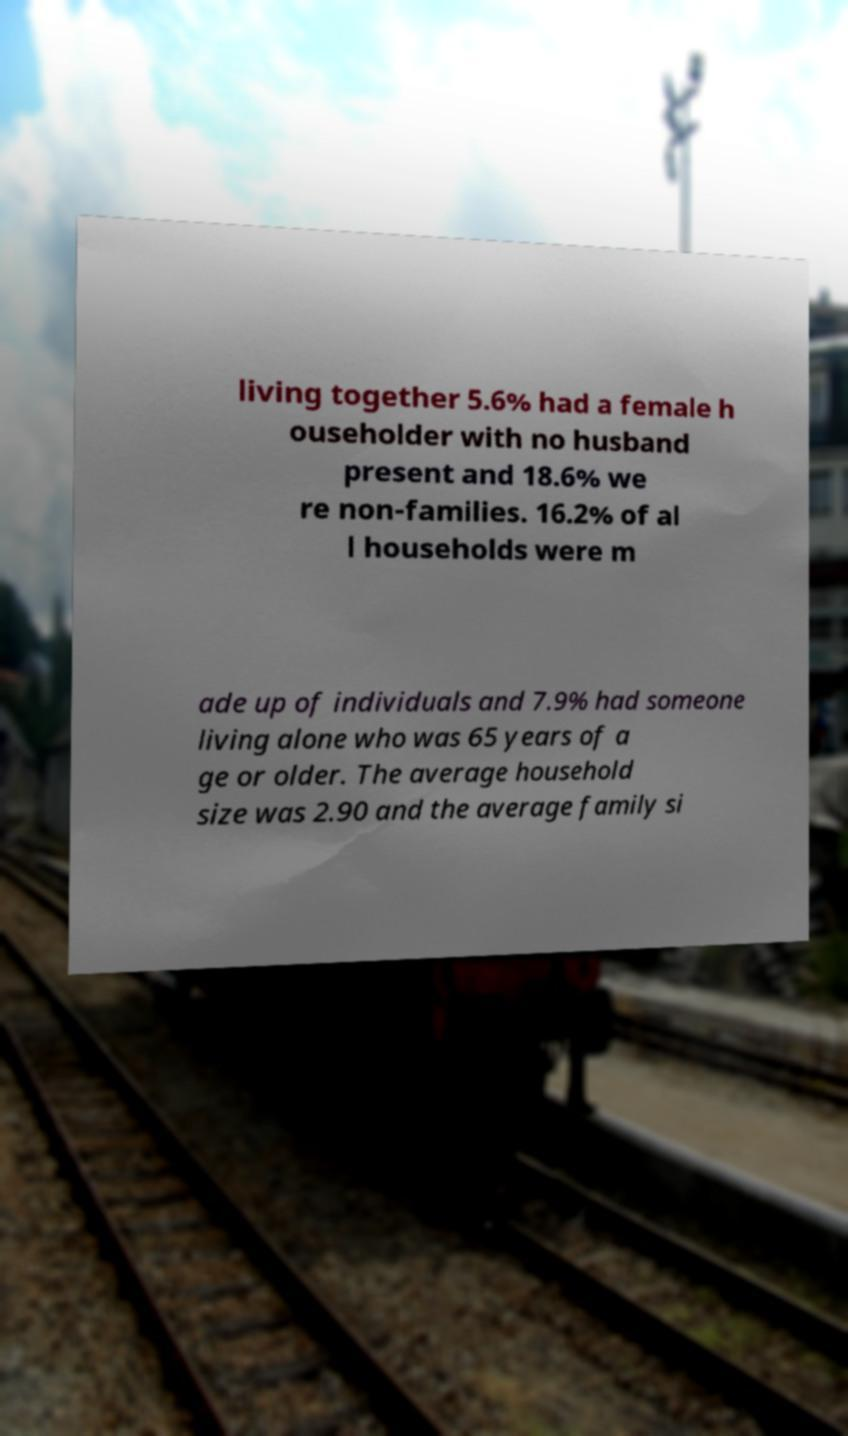There's text embedded in this image that I need extracted. Can you transcribe it verbatim? living together 5.6% had a female h ouseholder with no husband present and 18.6% we re non-families. 16.2% of al l households were m ade up of individuals and 7.9% had someone living alone who was 65 years of a ge or older. The average household size was 2.90 and the average family si 